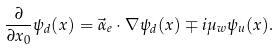<formula> <loc_0><loc_0><loc_500><loc_500>\frac { \partial } { \partial x _ { 0 } } \psi _ { d } ( x ) = \vec { \alpha } _ { e } \cdot \nabla \psi _ { d } ( x ) \mp i \mu _ { w } \psi _ { u } ( x ) .</formula> 